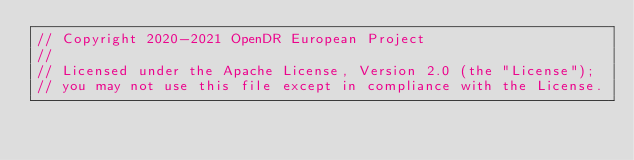<code> <loc_0><loc_0><loc_500><loc_500><_C++_>// Copyright 2020-2021 OpenDR European Project
//
// Licensed under the Apache License, Version 2.0 (the "License");
// you may not use this file except in compliance with the License.</code> 